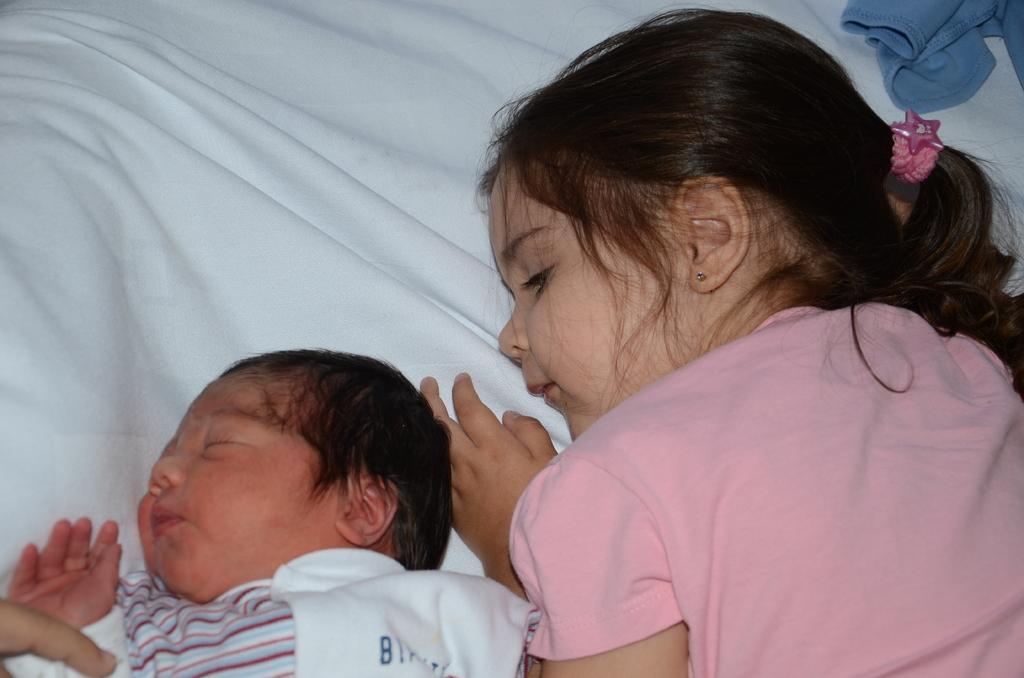Please provide a concise description of this image. In the image we can see a bed, on the bed two kids are lying. In the top right corner of the image we can see a cloth. 